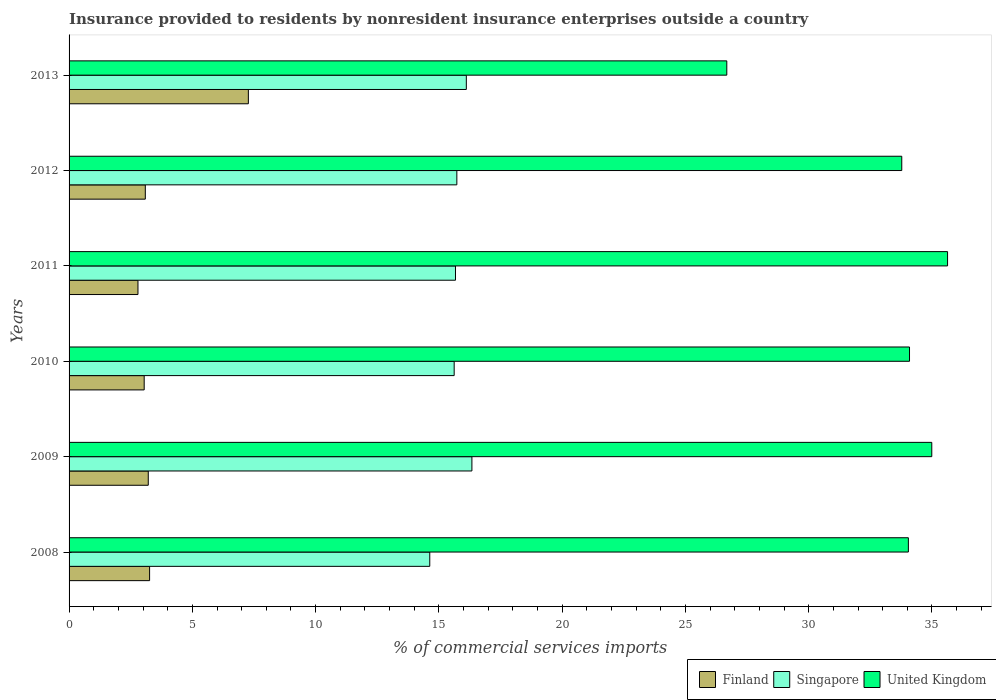Are the number of bars on each tick of the Y-axis equal?
Your answer should be compact. Yes. How many bars are there on the 3rd tick from the top?
Make the answer very short. 3. What is the Insurance provided to residents in Singapore in 2011?
Make the answer very short. 15.67. Across all years, what is the maximum Insurance provided to residents in Singapore?
Offer a terse response. 16.34. Across all years, what is the minimum Insurance provided to residents in United Kingdom?
Your answer should be compact. 26.68. In which year was the Insurance provided to residents in Singapore minimum?
Give a very brief answer. 2008. What is the total Insurance provided to residents in United Kingdom in the graph?
Ensure brevity in your answer.  199.21. What is the difference between the Insurance provided to residents in Finland in 2011 and that in 2013?
Offer a very short reply. -4.48. What is the difference between the Insurance provided to residents in United Kingdom in 2011 and the Insurance provided to residents in Finland in 2012?
Provide a succinct answer. 32.54. What is the average Insurance provided to residents in United Kingdom per year?
Provide a succinct answer. 33.2. In the year 2009, what is the difference between the Insurance provided to residents in Finland and Insurance provided to residents in United Kingdom?
Provide a succinct answer. -31.78. What is the ratio of the Insurance provided to residents in Singapore in 2011 to that in 2012?
Provide a succinct answer. 1. What is the difference between the highest and the second highest Insurance provided to residents in Finland?
Your answer should be compact. 4.01. What is the difference between the highest and the lowest Insurance provided to residents in Finland?
Offer a very short reply. 4.48. What does the 3rd bar from the top in 2008 represents?
Offer a terse response. Finland. What does the 2nd bar from the bottom in 2008 represents?
Keep it short and to the point. Singapore. Is it the case that in every year, the sum of the Insurance provided to residents in United Kingdom and Insurance provided to residents in Finland is greater than the Insurance provided to residents in Singapore?
Offer a very short reply. Yes. How many bars are there?
Your response must be concise. 18. Are all the bars in the graph horizontal?
Ensure brevity in your answer.  Yes. Does the graph contain grids?
Your answer should be very brief. No. What is the title of the graph?
Offer a very short reply. Insurance provided to residents by nonresident insurance enterprises outside a country. Does "Costa Rica" appear as one of the legend labels in the graph?
Make the answer very short. No. What is the label or title of the X-axis?
Provide a succinct answer. % of commercial services imports. What is the % of commercial services imports of Finland in 2008?
Provide a short and direct response. 3.27. What is the % of commercial services imports in Singapore in 2008?
Your answer should be compact. 14.63. What is the % of commercial services imports in United Kingdom in 2008?
Offer a very short reply. 34.04. What is the % of commercial services imports of Finland in 2009?
Make the answer very short. 3.21. What is the % of commercial services imports in Singapore in 2009?
Your answer should be compact. 16.34. What is the % of commercial services imports of United Kingdom in 2009?
Keep it short and to the point. 34.99. What is the % of commercial services imports of Finland in 2010?
Keep it short and to the point. 3.05. What is the % of commercial services imports of Singapore in 2010?
Ensure brevity in your answer.  15.62. What is the % of commercial services imports in United Kingdom in 2010?
Keep it short and to the point. 34.09. What is the % of commercial services imports of Finland in 2011?
Your response must be concise. 2.79. What is the % of commercial services imports of Singapore in 2011?
Ensure brevity in your answer.  15.67. What is the % of commercial services imports in United Kingdom in 2011?
Your answer should be very brief. 35.63. What is the % of commercial services imports of Finland in 2012?
Your response must be concise. 3.09. What is the % of commercial services imports in Singapore in 2012?
Offer a terse response. 15.73. What is the % of commercial services imports in United Kingdom in 2012?
Keep it short and to the point. 33.77. What is the % of commercial services imports in Finland in 2013?
Make the answer very short. 7.27. What is the % of commercial services imports in Singapore in 2013?
Ensure brevity in your answer.  16.11. What is the % of commercial services imports in United Kingdom in 2013?
Offer a very short reply. 26.68. Across all years, what is the maximum % of commercial services imports of Finland?
Provide a succinct answer. 7.27. Across all years, what is the maximum % of commercial services imports in Singapore?
Give a very brief answer. 16.34. Across all years, what is the maximum % of commercial services imports of United Kingdom?
Offer a terse response. 35.63. Across all years, what is the minimum % of commercial services imports in Finland?
Your response must be concise. 2.79. Across all years, what is the minimum % of commercial services imports of Singapore?
Provide a succinct answer. 14.63. Across all years, what is the minimum % of commercial services imports in United Kingdom?
Your answer should be very brief. 26.68. What is the total % of commercial services imports of Finland in the graph?
Your answer should be very brief. 22.68. What is the total % of commercial services imports of Singapore in the graph?
Provide a short and direct response. 94.1. What is the total % of commercial services imports in United Kingdom in the graph?
Make the answer very short. 199.21. What is the difference between the % of commercial services imports in Finland in 2008 and that in 2009?
Provide a succinct answer. 0.05. What is the difference between the % of commercial services imports in Singapore in 2008 and that in 2009?
Your answer should be compact. -1.71. What is the difference between the % of commercial services imports of United Kingdom in 2008 and that in 2009?
Provide a short and direct response. -0.95. What is the difference between the % of commercial services imports in Finland in 2008 and that in 2010?
Make the answer very short. 0.22. What is the difference between the % of commercial services imports in Singapore in 2008 and that in 2010?
Offer a very short reply. -0.99. What is the difference between the % of commercial services imports in United Kingdom in 2008 and that in 2010?
Offer a very short reply. -0.05. What is the difference between the % of commercial services imports of Finland in 2008 and that in 2011?
Your answer should be very brief. 0.47. What is the difference between the % of commercial services imports of Singapore in 2008 and that in 2011?
Your answer should be compact. -1.04. What is the difference between the % of commercial services imports of United Kingdom in 2008 and that in 2011?
Offer a terse response. -1.59. What is the difference between the % of commercial services imports of Finland in 2008 and that in 2012?
Make the answer very short. 0.17. What is the difference between the % of commercial services imports of Singapore in 2008 and that in 2012?
Offer a very short reply. -1.1. What is the difference between the % of commercial services imports of United Kingdom in 2008 and that in 2012?
Provide a succinct answer. 0.27. What is the difference between the % of commercial services imports in Finland in 2008 and that in 2013?
Ensure brevity in your answer.  -4.01. What is the difference between the % of commercial services imports of Singapore in 2008 and that in 2013?
Your answer should be compact. -1.48. What is the difference between the % of commercial services imports in United Kingdom in 2008 and that in 2013?
Your response must be concise. 7.36. What is the difference between the % of commercial services imports in Finland in 2009 and that in 2010?
Your answer should be very brief. 0.17. What is the difference between the % of commercial services imports in Singapore in 2009 and that in 2010?
Give a very brief answer. 0.72. What is the difference between the % of commercial services imports of United Kingdom in 2009 and that in 2010?
Provide a short and direct response. 0.9. What is the difference between the % of commercial services imports in Finland in 2009 and that in 2011?
Provide a short and direct response. 0.42. What is the difference between the % of commercial services imports in Singapore in 2009 and that in 2011?
Your response must be concise. 0.67. What is the difference between the % of commercial services imports of United Kingdom in 2009 and that in 2011?
Your answer should be very brief. -0.64. What is the difference between the % of commercial services imports in Finland in 2009 and that in 2012?
Keep it short and to the point. 0.12. What is the difference between the % of commercial services imports of Singapore in 2009 and that in 2012?
Make the answer very short. 0.61. What is the difference between the % of commercial services imports in United Kingdom in 2009 and that in 2012?
Make the answer very short. 1.22. What is the difference between the % of commercial services imports in Finland in 2009 and that in 2013?
Offer a terse response. -4.06. What is the difference between the % of commercial services imports of Singapore in 2009 and that in 2013?
Provide a short and direct response. 0.23. What is the difference between the % of commercial services imports in United Kingdom in 2009 and that in 2013?
Offer a very short reply. 8.31. What is the difference between the % of commercial services imports of Finland in 2010 and that in 2011?
Offer a terse response. 0.25. What is the difference between the % of commercial services imports in Singapore in 2010 and that in 2011?
Make the answer very short. -0.05. What is the difference between the % of commercial services imports of United Kingdom in 2010 and that in 2011?
Provide a succinct answer. -1.54. What is the difference between the % of commercial services imports in Finland in 2010 and that in 2012?
Keep it short and to the point. -0.05. What is the difference between the % of commercial services imports in Singapore in 2010 and that in 2012?
Offer a terse response. -0.11. What is the difference between the % of commercial services imports in United Kingdom in 2010 and that in 2012?
Keep it short and to the point. 0.31. What is the difference between the % of commercial services imports of Finland in 2010 and that in 2013?
Your response must be concise. -4.23. What is the difference between the % of commercial services imports of Singapore in 2010 and that in 2013?
Your response must be concise. -0.49. What is the difference between the % of commercial services imports of United Kingdom in 2010 and that in 2013?
Offer a very short reply. 7.41. What is the difference between the % of commercial services imports in Finland in 2011 and that in 2012?
Your answer should be very brief. -0.3. What is the difference between the % of commercial services imports of Singapore in 2011 and that in 2012?
Ensure brevity in your answer.  -0.05. What is the difference between the % of commercial services imports of United Kingdom in 2011 and that in 2012?
Give a very brief answer. 1.86. What is the difference between the % of commercial services imports of Finland in 2011 and that in 2013?
Your response must be concise. -4.48. What is the difference between the % of commercial services imports of Singapore in 2011 and that in 2013?
Make the answer very short. -0.44. What is the difference between the % of commercial services imports of United Kingdom in 2011 and that in 2013?
Ensure brevity in your answer.  8.95. What is the difference between the % of commercial services imports of Finland in 2012 and that in 2013?
Provide a succinct answer. -4.18. What is the difference between the % of commercial services imports of Singapore in 2012 and that in 2013?
Provide a succinct answer. -0.38. What is the difference between the % of commercial services imports of United Kingdom in 2012 and that in 2013?
Provide a succinct answer. 7.1. What is the difference between the % of commercial services imports of Finland in 2008 and the % of commercial services imports of Singapore in 2009?
Offer a terse response. -13.07. What is the difference between the % of commercial services imports of Finland in 2008 and the % of commercial services imports of United Kingdom in 2009?
Your answer should be compact. -31.73. What is the difference between the % of commercial services imports in Singapore in 2008 and the % of commercial services imports in United Kingdom in 2009?
Offer a terse response. -20.36. What is the difference between the % of commercial services imports in Finland in 2008 and the % of commercial services imports in Singapore in 2010?
Your response must be concise. -12.35. What is the difference between the % of commercial services imports in Finland in 2008 and the % of commercial services imports in United Kingdom in 2010?
Your answer should be compact. -30.82. What is the difference between the % of commercial services imports of Singapore in 2008 and the % of commercial services imports of United Kingdom in 2010?
Offer a very short reply. -19.46. What is the difference between the % of commercial services imports of Finland in 2008 and the % of commercial services imports of Singapore in 2011?
Ensure brevity in your answer.  -12.41. What is the difference between the % of commercial services imports in Finland in 2008 and the % of commercial services imports in United Kingdom in 2011?
Your answer should be compact. -32.37. What is the difference between the % of commercial services imports in Singapore in 2008 and the % of commercial services imports in United Kingdom in 2011?
Offer a very short reply. -21. What is the difference between the % of commercial services imports in Finland in 2008 and the % of commercial services imports in Singapore in 2012?
Offer a terse response. -12.46. What is the difference between the % of commercial services imports in Finland in 2008 and the % of commercial services imports in United Kingdom in 2012?
Provide a succinct answer. -30.51. What is the difference between the % of commercial services imports in Singapore in 2008 and the % of commercial services imports in United Kingdom in 2012?
Provide a short and direct response. -19.14. What is the difference between the % of commercial services imports of Finland in 2008 and the % of commercial services imports of Singapore in 2013?
Provide a short and direct response. -12.85. What is the difference between the % of commercial services imports of Finland in 2008 and the % of commercial services imports of United Kingdom in 2013?
Offer a very short reply. -23.41. What is the difference between the % of commercial services imports of Singapore in 2008 and the % of commercial services imports of United Kingdom in 2013?
Provide a succinct answer. -12.05. What is the difference between the % of commercial services imports of Finland in 2009 and the % of commercial services imports of Singapore in 2010?
Ensure brevity in your answer.  -12.41. What is the difference between the % of commercial services imports of Finland in 2009 and the % of commercial services imports of United Kingdom in 2010?
Your response must be concise. -30.88. What is the difference between the % of commercial services imports in Singapore in 2009 and the % of commercial services imports in United Kingdom in 2010?
Keep it short and to the point. -17.75. What is the difference between the % of commercial services imports in Finland in 2009 and the % of commercial services imports in Singapore in 2011?
Provide a short and direct response. -12.46. What is the difference between the % of commercial services imports of Finland in 2009 and the % of commercial services imports of United Kingdom in 2011?
Offer a terse response. -32.42. What is the difference between the % of commercial services imports in Singapore in 2009 and the % of commercial services imports in United Kingdom in 2011?
Your answer should be very brief. -19.29. What is the difference between the % of commercial services imports in Finland in 2009 and the % of commercial services imports in Singapore in 2012?
Your response must be concise. -12.52. What is the difference between the % of commercial services imports in Finland in 2009 and the % of commercial services imports in United Kingdom in 2012?
Keep it short and to the point. -30.56. What is the difference between the % of commercial services imports of Singapore in 2009 and the % of commercial services imports of United Kingdom in 2012?
Keep it short and to the point. -17.44. What is the difference between the % of commercial services imports of Finland in 2009 and the % of commercial services imports of Singapore in 2013?
Make the answer very short. -12.9. What is the difference between the % of commercial services imports in Finland in 2009 and the % of commercial services imports in United Kingdom in 2013?
Keep it short and to the point. -23.47. What is the difference between the % of commercial services imports in Singapore in 2009 and the % of commercial services imports in United Kingdom in 2013?
Your answer should be very brief. -10.34. What is the difference between the % of commercial services imports of Finland in 2010 and the % of commercial services imports of Singapore in 2011?
Offer a terse response. -12.63. What is the difference between the % of commercial services imports in Finland in 2010 and the % of commercial services imports in United Kingdom in 2011?
Keep it short and to the point. -32.59. What is the difference between the % of commercial services imports in Singapore in 2010 and the % of commercial services imports in United Kingdom in 2011?
Provide a short and direct response. -20.01. What is the difference between the % of commercial services imports of Finland in 2010 and the % of commercial services imports of Singapore in 2012?
Make the answer very short. -12.68. What is the difference between the % of commercial services imports of Finland in 2010 and the % of commercial services imports of United Kingdom in 2012?
Offer a very short reply. -30.73. What is the difference between the % of commercial services imports in Singapore in 2010 and the % of commercial services imports in United Kingdom in 2012?
Your answer should be compact. -18.16. What is the difference between the % of commercial services imports in Finland in 2010 and the % of commercial services imports in Singapore in 2013?
Offer a very short reply. -13.07. What is the difference between the % of commercial services imports of Finland in 2010 and the % of commercial services imports of United Kingdom in 2013?
Give a very brief answer. -23.63. What is the difference between the % of commercial services imports in Singapore in 2010 and the % of commercial services imports in United Kingdom in 2013?
Keep it short and to the point. -11.06. What is the difference between the % of commercial services imports in Finland in 2011 and the % of commercial services imports in Singapore in 2012?
Offer a terse response. -12.93. What is the difference between the % of commercial services imports in Finland in 2011 and the % of commercial services imports in United Kingdom in 2012?
Your answer should be very brief. -30.98. What is the difference between the % of commercial services imports of Singapore in 2011 and the % of commercial services imports of United Kingdom in 2012?
Your answer should be compact. -18.1. What is the difference between the % of commercial services imports of Finland in 2011 and the % of commercial services imports of Singapore in 2013?
Provide a short and direct response. -13.32. What is the difference between the % of commercial services imports of Finland in 2011 and the % of commercial services imports of United Kingdom in 2013?
Your response must be concise. -23.88. What is the difference between the % of commercial services imports of Singapore in 2011 and the % of commercial services imports of United Kingdom in 2013?
Give a very brief answer. -11. What is the difference between the % of commercial services imports of Finland in 2012 and the % of commercial services imports of Singapore in 2013?
Ensure brevity in your answer.  -13.02. What is the difference between the % of commercial services imports of Finland in 2012 and the % of commercial services imports of United Kingdom in 2013?
Your answer should be compact. -23.59. What is the difference between the % of commercial services imports of Singapore in 2012 and the % of commercial services imports of United Kingdom in 2013?
Offer a very short reply. -10.95. What is the average % of commercial services imports in Finland per year?
Keep it short and to the point. 3.78. What is the average % of commercial services imports of Singapore per year?
Ensure brevity in your answer.  15.68. What is the average % of commercial services imports in United Kingdom per year?
Your response must be concise. 33.2. In the year 2008, what is the difference between the % of commercial services imports in Finland and % of commercial services imports in Singapore?
Keep it short and to the point. -11.36. In the year 2008, what is the difference between the % of commercial services imports in Finland and % of commercial services imports in United Kingdom?
Offer a very short reply. -30.78. In the year 2008, what is the difference between the % of commercial services imports of Singapore and % of commercial services imports of United Kingdom?
Provide a short and direct response. -19.41. In the year 2009, what is the difference between the % of commercial services imports in Finland and % of commercial services imports in Singapore?
Provide a succinct answer. -13.13. In the year 2009, what is the difference between the % of commercial services imports of Finland and % of commercial services imports of United Kingdom?
Provide a short and direct response. -31.78. In the year 2009, what is the difference between the % of commercial services imports of Singapore and % of commercial services imports of United Kingdom?
Ensure brevity in your answer.  -18.65. In the year 2010, what is the difference between the % of commercial services imports of Finland and % of commercial services imports of Singapore?
Your answer should be very brief. -12.57. In the year 2010, what is the difference between the % of commercial services imports of Finland and % of commercial services imports of United Kingdom?
Your answer should be compact. -31.04. In the year 2010, what is the difference between the % of commercial services imports of Singapore and % of commercial services imports of United Kingdom?
Offer a very short reply. -18.47. In the year 2011, what is the difference between the % of commercial services imports in Finland and % of commercial services imports in Singapore?
Provide a short and direct response. -12.88. In the year 2011, what is the difference between the % of commercial services imports in Finland and % of commercial services imports in United Kingdom?
Offer a very short reply. -32.84. In the year 2011, what is the difference between the % of commercial services imports in Singapore and % of commercial services imports in United Kingdom?
Your answer should be compact. -19.96. In the year 2012, what is the difference between the % of commercial services imports of Finland and % of commercial services imports of Singapore?
Your answer should be very brief. -12.64. In the year 2012, what is the difference between the % of commercial services imports in Finland and % of commercial services imports in United Kingdom?
Make the answer very short. -30.68. In the year 2012, what is the difference between the % of commercial services imports of Singapore and % of commercial services imports of United Kingdom?
Provide a short and direct response. -18.05. In the year 2013, what is the difference between the % of commercial services imports of Finland and % of commercial services imports of Singapore?
Provide a short and direct response. -8.84. In the year 2013, what is the difference between the % of commercial services imports of Finland and % of commercial services imports of United Kingdom?
Your answer should be very brief. -19.41. In the year 2013, what is the difference between the % of commercial services imports of Singapore and % of commercial services imports of United Kingdom?
Your response must be concise. -10.57. What is the ratio of the % of commercial services imports of Finland in 2008 to that in 2009?
Your answer should be compact. 1.02. What is the ratio of the % of commercial services imports of Singapore in 2008 to that in 2009?
Your answer should be compact. 0.9. What is the ratio of the % of commercial services imports in United Kingdom in 2008 to that in 2009?
Give a very brief answer. 0.97. What is the ratio of the % of commercial services imports in Finland in 2008 to that in 2010?
Ensure brevity in your answer.  1.07. What is the ratio of the % of commercial services imports of Singapore in 2008 to that in 2010?
Your response must be concise. 0.94. What is the ratio of the % of commercial services imports in Finland in 2008 to that in 2011?
Provide a succinct answer. 1.17. What is the ratio of the % of commercial services imports in Singapore in 2008 to that in 2011?
Offer a terse response. 0.93. What is the ratio of the % of commercial services imports in United Kingdom in 2008 to that in 2011?
Your answer should be compact. 0.96. What is the ratio of the % of commercial services imports of Finland in 2008 to that in 2012?
Your answer should be compact. 1.06. What is the ratio of the % of commercial services imports of Singapore in 2008 to that in 2012?
Your answer should be compact. 0.93. What is the ratio of the % of commercial services imports in United Kingdom in 2008 to that in 2012?
Make the answer very short. 1.01. What is the ratio of the % of commercial services imports of Finland in 2008 to that in 2013?
Keep it short and to the point. 0.45. What is the ratio of the % of commercial services imports in Singapore in 2008 to that in 2013?
Offer a very short reply. 0.91. What is the ratio of the % of commercial services imports of United Kingdom in 2008 to that in 2013?
Your response must be concise. 1.28. What is the ratio of the % of commercial services imports in Finland in 2009 to that in 2010?
Make the answer very short. 1.05. What is the ratio of the % of commercial services imports of Singapore in 2009 to that in 2010?
Your response must be concise. 1.05. What is the ratio of the % of commercial services imports in United Kingdom in 2009 to that in 2010?
Offer a terse response. 1.03. What is the ratio of the % of commercial services imports of Finland in 2009 to that in 2011?
Make the answer very short. 1.15. What is the ratio of the % of commercial services imports of Singapore in 2009 to that in 2011?
Your answer should be compact. 1.04. What is the ratio of the % of commercial services imports in United Kingdom in 2009 to that in 2011?
Your response must be concise. 0.98. What is the ratio of the % of commercial services imports in Finland in 2009 to that in 2012?
Your answer should be compact. 1.04. What is the ratio of the % of commercial services imports in Singapore in 2009 to that in 2012?
Provide a short and direct response. 1.04. What is the ratio of the % of commercial services imports of United Kingdom in 2009 to that in 2012?
Provide a short and direct response. 1.04. What is the ratio of the % of commercial services imports of Finland in 2009 to that in 2013?
Offer a terse response. 0.44. What is the ratio of the % of commercial services imports of United Kingdom in 2009 to that in 2013?
Your answer should be compact. 1.31. What is the ratio of the % of commercial services imports in Finland in 2010 to that in 2011?
Give a very brief answer. 1.09. What is the ratio of the % of commercial services imports in United Kingdom in 2010 to that in 2011?
Provide a succinct answer. 0.96. What is the ratio of the % of commercial services imports of Singapore in 2010 to that in 2012?
Your answer should be compact. 0.99. What is the ratio of the % of commercial services imports in United Kingdom in 2010 to that in 2012?
Offer a terse response. 1.01. What is the ratio of the % of commercial services imports in Finland in 2010 to that in 2013?
Offer a very short reply. 0.42. What is the ratio of the % of commercial services imports in Singapore in 2010 to that in 2013?
Your response must be concise. 0.97. What is the ratio of the % of commercial services imports in United Kingdom in 2010 to that in 2013?
Offer a terse response. 1.28. What is the ratio of the % of commercial services imports in Finland in 2011 to that in 2012?
Keep it short and to the point. 0.9. What is the ratio of the % of commercial services imports in United Kingdom in 2011 to that in 2012?
Offer a very short reply. 1.05. What is the ratio of the % of commercial services imports in Finland in 2011 to that in 2013?
Offer a very short reply. 0.38. What is the ratio of the % of commercial services imports in Singapore in 2011 to that in 2013?
Provide a succinct answer. 0.97. What is the ratio of the % of commercial services imports of United Kingdom in 2011 to that in 2013?
Make the answer very short. 1.34. What is the ratio of the % of commercial services imports in Finland in 2012 to that in 2013?
Offer a very short reply. 0.43. What is the ratio of the % of commercial services imports in Singapore in 2012 to that in 2013?
Offer a terse response. 0.98. What is the ratio of the % of commercial services imports in United Kingdom in 2012 to that in 2013?
Your answer should be compact. 1.27. What is the difference between the highest and the second highest % of commercial services imports in Finland?
Your answer should be very brief. 4.01. What is the difference between the highest and the second highest % of commercial services imports in Singapore?
Ensure brevity in your answer.  0.23. What is the difference between the highest and the second highest % of commercial services imports of United Kingdom?
Ensure brevity in your answer.  0.64. What is the difference between the highest and the lowest % of commercial services imports of Finland?
Offer a very short reply. 4.48. What is the difference between the highest and the lowest % of commercial services imports of Singapore?
Provide a succinct answer. 1.71. What is the difference between the highest and the lowest % of commercial services imports of United Kingdom?
Offer a very short reply. 8.95. 